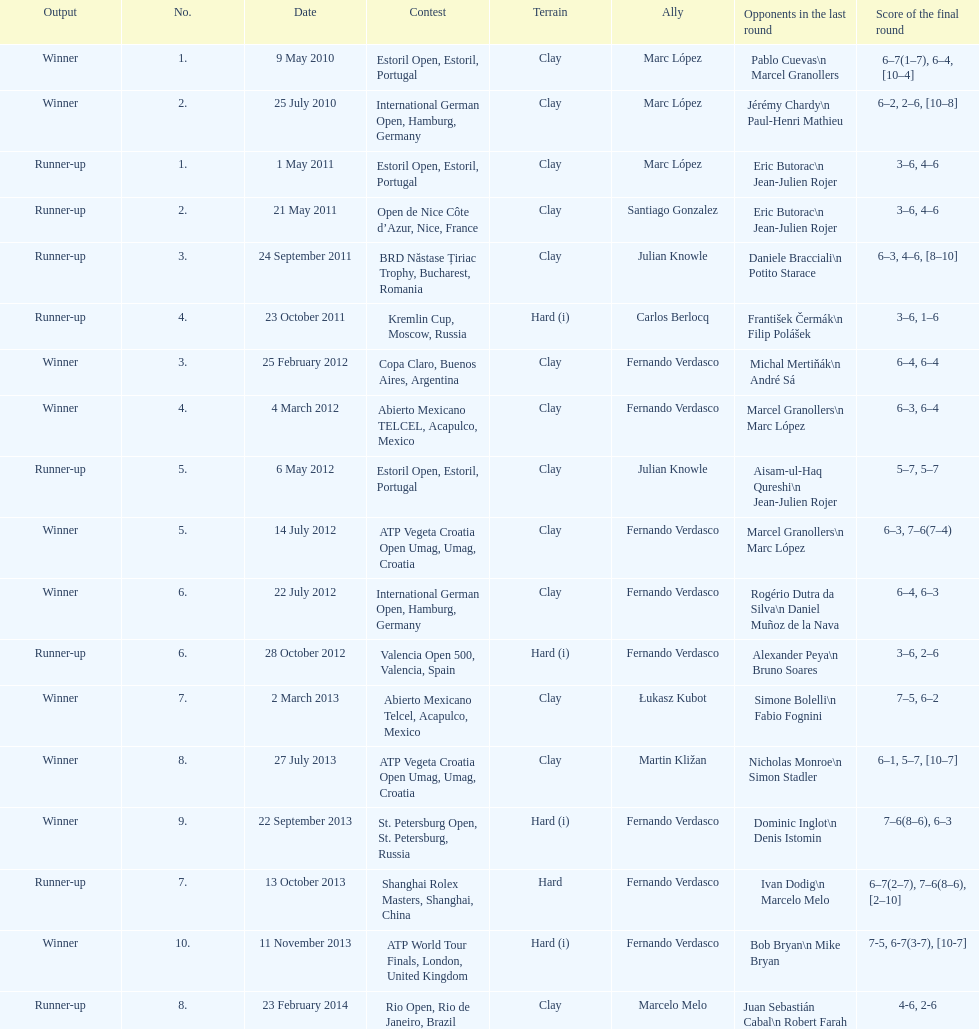Parse the table in full. {'header': ['Output', 'No.', 'Date', 'Contest', 'Terrain', 'Ally', 'Opponents in the last round', 'Score of the final round'], 'rows': [['Winner', '1.', '9 May 2010', 'Estoril Open, Estoril, Portugal', 'Clay', 'Marc López', 'Pablo Cuevas\\n Marcel Granollers', '6–7(1–7), 6–4, [10–4]'], ['Winner', '2.', '25 July 2010', 'International German Open, Hamburg, Germany', 'Clay', 'Marc López', 'Jérémy Chardy\\n Paul-Henri Mathieu', '6–2, 2–6, [10–8]'], ['Runner-up', '1.', '1 May 2011', 'Estoril Open, Estoril, Portugal', 'Clay', 'Marc López', 'Eric Butorac\\n Jean-Julien Rojer', '3–6, 4–6'], ['Runner-up', '2.', '21 May 2011', 'Open de Nice Côte d’Azur, Nice, France', 'Clay', 'Santiago Gonzalez', 'Eric Butorac\\n Jean-Julien Rojer', '3–6, 4–6'], ['Runner-up', '3.', '24 September 2011', 'BRD Năstase Țiriac Trophy, Bucharest, Romania', 'Clay', 'Julian Knowle', 'Daniele Bracciali\\n Potito Starace', '6–3, 4–6, [8–10]'], ['Runner-up', '4.', '23 October 2011', 'Kremlin Cup, Moscow, Russia', 'Hard (i)', 'Carlos Berlocq', 'František Čermák\\n Filip Polášek', '3–6, 1–6'], ['Winner', '3.', '25 February 2012', 'Copa Claro, Buenos Aires, Argentina', 'Clay', 'Fernando Verdasco', 'Michal Mertiňák\\n André Sá', '6–4, 6–4'], ['Winner', '4.', '4 March 2012', 'Abierto Mexicano TELCEL, Acapulco, Mexico', 'Clay', 'Fernando Verdasco', 'Marcel Granollers\\n Marc López', '6–3, 6–4'], ['Runner-up', '5.', '6 May 2012', 'Estoril Open, Estoril, Portugal', 'Clay', 'Julian Knowle', 'Aisam-ul-Haq Qureshi\\n Jean-Julien Rojer', '5–7, 5–7'], ['Winner', '5.', '14 July 2012', 'ATP Vegeta Croatia Open Umag, Umag, Croatia', 'Clay', 'Fernando Verdasco', 'Marcel Granollers\\n Marc López', '6–3, 7–6(7–4)'], ['Winner', '6.', '22 July 2012', 'International German Open, Hamburg, Germany', 'Clay', 'Fernando Verdasco', 'Rogério Dutra da Silva\\n Daniel Muñoz de la Nava', '6–4, 6–3'], ['Runner-up', '6.', '28 October 2012', 'Valencia Open 500, Valencia, Spain', 'Hard (i)', 'Fernando Verdasco', 'Alexander Peya\\n Bruno Soares', '3–6, 2–6'], ['Winner', '7.', '2 March 2013', 'Abierto Mexicano Telcel, Acapulco, Mexico', 'Clay', 'Łukasz Kubot', 'Simone Bolelli\\n Fabio Fognini', '7–5, 6–2'], ['Winner', '8.', '27 July 2013', 'ATP Vegeta Croatia Open Umag, Umag, Croatia', 'Clay', 'Martin Kližan', 'Nicholas Monroe\\n Simon Stadler', '6–1, 5–7, [10–7]'], ['Winner', '9.', '22 September 2013', 'St. Petersburg Open, St. Petersburg, Russia', 'Hard (i)', 'Fernando Verdasco', 'Dominic Inglot\\n Denis Istomin', '7–6(8–6), 6–3'], ['Runner-up', '7.', '13 October 2013', 'Shanghai Rolex Masters, Shanghai, China', 'Hard', 'Fernando Verdasco', 'Ivan Dodig\\n Marcelo Melo', '6–7(2–7), 7–6(8–6), [2–10]'], ['Winner', '10.', '11 November 2013', 'ATP World Tour Finals, London, United Kingdom', 'Hard (i)', 'Fernando Verdasco', 'Bob Bryan\\n Mike Bryan', '7-5, 6-7(3-7), [10-7]'], ['Runner-up', '8.', '23 February 2014', 'Rio Open, Rio de Janeiro, Brazil', 'Clay', 'Marcelo Melo', 'Juan Sebastián Cabal\\n Robert Farah', '4-6, 2-6']]} What is the sum of runner-ups displayed on the chart? 8. 